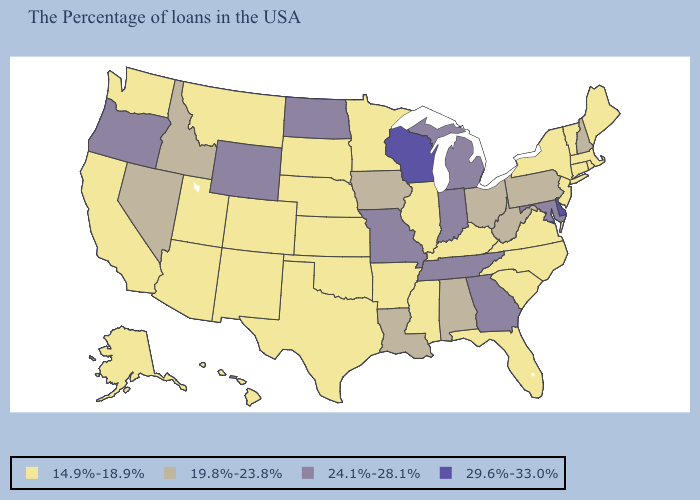What is the lowest value in the MidWest?
Short answer required. 14.9%-18.9%. Does Wisconsin have a higher value than Delaware?
Quick response, please. No. What is the value of South Carolina?
Concise answer only. 14.9%-18.9%. What is the lowest value in the USA?
Give a very brief answer. 14.9%-18.9%. Does Arkansas have the same value as Louisiana?
Answer briefly. No. Does the first symbol in the legend represent the smallest category?
Quick response, please. Yes. What is the highest value in states that border New Mexico?
Give a very brief answer. 14.9%-18.9%. Does Illinois have the lowest value in the USA?
Quick response, please. Yes. Which states hav the highest value in the Northeast?
Short answer required. New Hampshire, Pennsylvania. What is the value of Nebraska?
Short answer required. 14.9%-18.9%. Name the states that have a value in the range 24.1%-28.1%?
Answer briefly. Maryland, Georgia, Michigan, Indiana, Tennessee, Missouri, North Dakota, Wyoming, Oregon. What is the value of Louisiana?
Keep it brief. 19.8%-23.8%. What is the lowest value in the MidWest?
Concise answer only. 14.9%-18.9%. Among the states that border Colorado , which have the lowest value?
Be succinct. Kansas, Nebraska, Oklahoma, New Mexico, Utah, Arizona. 